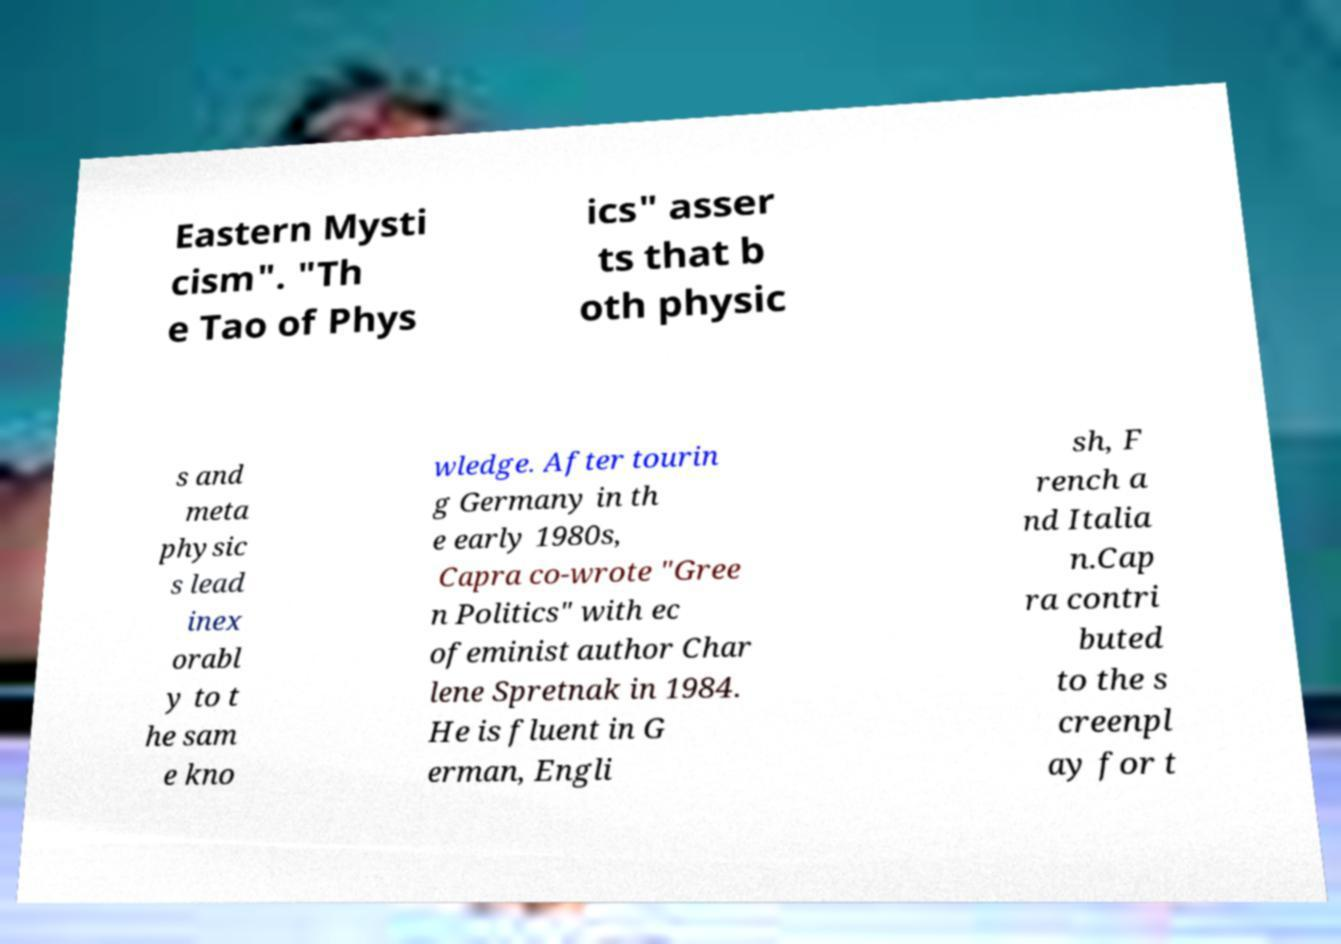Can you read and provide the text displayed in the image?This photo seems to have some interesting text. Can you extract and type it out for me? Eastern Mysti cism". "Th e Tao of Phys ics" asser ts that b oth physic s and meta physic s lead inex orabl y to t he sam e kno wledge. After tourin g Germany in th e early 1980s, Capra co-wrote "Gree n Politics" with ec ofeminist author Char lene Spretnak in 1984. He is fluent in G erman, Engli sh, F rench a nd Italia n.Cap ra contri buted to the s creenpl ay for t 